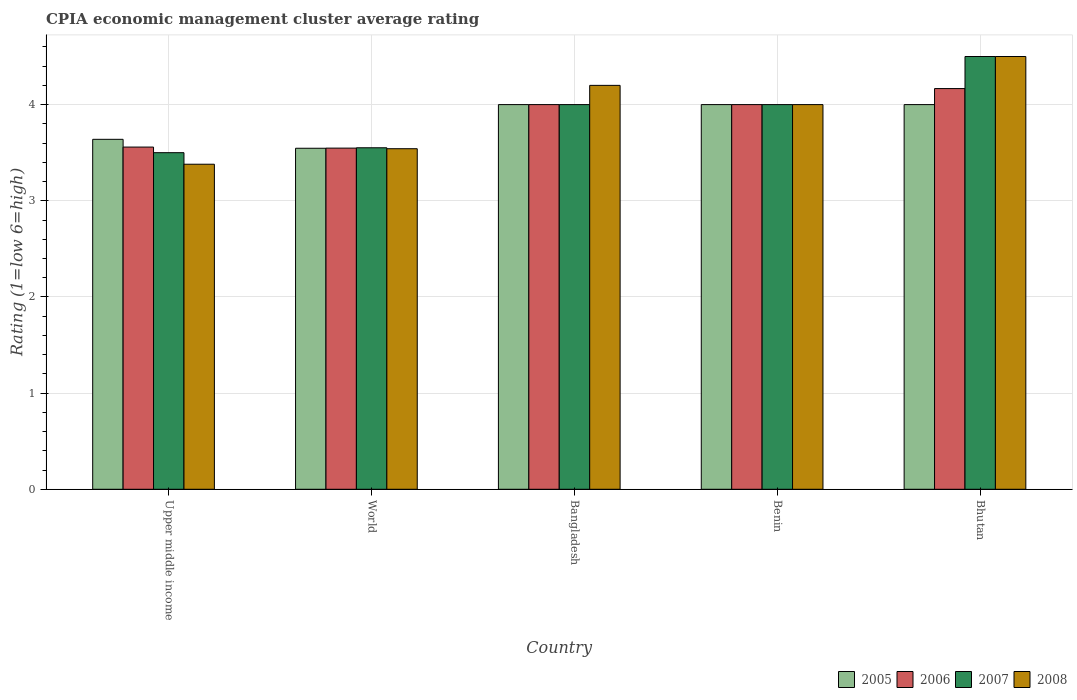Are the number of bars per tick equal to the number of legend labels?
Offer a terse response. Yes. Across all countries, what is the maximum CPIA rating in 2006?
Provide a succinct answer. 4.17. Across all countries, what is the minimum CPIA rating in 2006?
Keep it short and to the point. 3.55. In which country was the CPIA rating in 2008 minimum?
Ensure brevity in your answer.  Upper middle income. What is the total CPIA rating in 2006 in the graph?
Keep it short and to the point. 19.27. What is the difference between the CPIA rating in 2005 in Bangladesh and that in Bhutan?
Make the answer very short. 0. What is the difference between the CPIA rating in 2006 in Upper middle income and the CPIA rating in 2005 in Bhutan?
Provide a succinct answer. -0.44. What is the average CPIA rating in 2007 per country?
Make the answer very short. 3.91. What is the difference between the CPIA rating of/in 2007 and CPIA rating of/in 2006 in Benin?
Ensure brevity in your answer.  0. What is the ratio of the CPIA rating in 2008 in Bhutan to that in World?
Give a very brief answer. 1.27. Is the difference between the CPIA rating in 2007 in Bangladesh and Bhutan greater than the difference between the CPIA rating in 2006 in Bangladesh and Bhutan?
Provide a short and direct response. No. What is the difference between the highest and the lowest CPIA rating in 2007?
Ensure brevity in your answer.  1. Is the sum of the CPIA rating in 2006 in Bangladesh and World greater than the maximum CPIA rating in 2007 across all countries?
Offer a terse response. Yes. Is it the case that in every country, the sum of the CPIA rating in 2007 and CPIA rating in 2005 is greater than the sum of CPIA rating in 2008 and CPIA rating in 2006?
Offer a terse response. No. What does the 1st bar from the left in World represents?
Your answer should be very brief. 2005. What does the 4th bar from the right in Upper middle income represents?
Give a very brief answer. 2005. Is it the case that in every country, the sum of the CPIA rating in 2008 and CPIA rating in 2007 is greater than the CPIA rating in 2005?
Make the answer very short. Yes. What is the difference between two consecutive major ticks on the Y-axis?
Your answer should be compact. 1. Are the values on the major ticks of Y-axis written in scientific E-notation?
Offer a very short reply. No. Does the graph contain grids?
Keep it short and to the point. Yes. Where does the legend appear in the graph?
Make the answer very short. Bottom right. How many legend labels are there?
Make the answer very short. 4. What is the title of the graph?
Provide a short and direct response. CPIA economic management cluster average rating. Does "1989" appear as one of the legend labels in the graph?
Make the answer very short. No. What is the label or title of the Y-axis?
Give a very brief answer. Rating (1=low 6=high). What is the Rating (1=low 6=high) in 2005 in Upper middle income?
Make the answer very short. 3.64. What is the Rating (1=low 6=high) of 2006 in Upper middle income?
Provide a short and direct response. 3.56. What is the Rating (1=low 6=high) in 2007 in Upper middle income?
Make the answer very short. 3.5. What is the Rating (1=low 6=high) of 2008 in Upper middle income?
Provide a succinct answer. 3.38. What is the Rating (1=low 6=high) of 2005 in World?
Make the answer very short. 3.55. What is the Rating (1=low 6=high) in 2006 in World?
Give a very brief answer. 3.55. What is the Rating (1=low 6=high) of 2007 in World?
Keep it short and to the point. 3.55. What is the Rating (1=low 6=high) of 2008 in World?
Your answer should be compact. 3.54. What is the Rating (1=low 6=high) in 2005 in Bangladesh?
Your response must be concise. 4. What is the Rating (1=low 6=high) in 2007 in Bangladesh?
Keep it short and to the point. 4. What is the Rating (1=low 6=high) in 2008 in Bangladesh?
Your response must be concise. 4.2. What is the Rating (1=low 6=high) in 2005 in Benin?
Keep it short and to the point. 4. What is the Rating (1=low 6=high) of 2006 in Benin?
Offer a terse response. 4. What is the Rating (1=low 6=high) in 2005 in Bhutan?
Keep it short and to the point. 4. What is the Rating (1=low 6=high) in 2006 in Bhutan?
Provide a short and direct response. 4.17. What is the Rating (1=low 6=high) in 2008 in Bhutan?
Ensure brevity in your answer.  4.5. Across all countries, what is the maximum Rating (1=low 6=high) of 2006?
Make the answer very short. 4.17. Across all countries, what is the minimum Rating (1=low 6=high) of 2005?
Provide a short and direct response. 3.55. Across all countries, what is the minimum Rating (1=low 6=high) in 2006?
Your answer should be compact. 3.55. Across all countries, what is the minimum Rating (1=low 6=high) in 2007?
Your answer should be compact. 3.5. Across all countries, what is the minimum Rating (1=low 6=high) of 2008?
Give a very brief answer. 3.38. What is the total Rating (1=low 6=high) of 2005 in the graph?
Give a very brief answer. 19.18. What is the total Rating (1=low 6=high) in 2006 in the graph?
Give a very brief answer. 19.27. What is the total Rating (1=low 6=high) in 2007 in the graph?
Provide a succinct answer. 19.55. What is the total Rating (1=low 6=high) of 2008 in the graph?
Your answer should be compact. 19.62. What is the difference between the Rating (1=low 6=high) of 2005 in Upper middle income and that in World?
Your response must be concise. 0.09. What is the difference between the Rating (1=low 6=high) of 2006 in Upper middle income and that in World?
Your answer should be very brief. 0.01. What is the difference between the Rating (1=low 6=high) of 2007 in Upper middle income and that in World?
Your answer should be very brief. -0.05. What is the difference between the Rating (1=low 6=high) of 2008 in Upper middle income and that in World?
Offer a terse response. -0.16. What is the difference between the Rating (1=low 6=high) of 2005 in Upper middle income and that in Bangladesh?
Provide a short and direct response. -0.36. What is the difference between the Rating (1=low 6=high) of 2006 in Upper middle income and that in Bangladesh?
Offer a terse response. -0.44. What is the difference between the Rating (1=low 6=high) in 2008 in Upper middle income and that in Bangladesh?
Your answer should be compact. -0.82. What is the difference between the Rating (1=low 6=high) in 2005 in Upper middle income and that in Benin?
Your answer should be very brief. -0.36. What is the difference between the Rating (1=low 6=high) in 2006 in Upper middle income and that in Benin?
Make the answer very short. -0.44. What is the difference between the Rating (1=low 6=high) of 2008 in Upper middle income and that in Benin?
Make the answer very short. -0.62. What is the difference between the Rating (1=low 6=high) in 2005 in Upper middle income and that in Bhutan?
Offer a very short reply. -0.36. What is the difference between the Rating (1=low 6=high) in 2006 in Upper middle income and that in Bhutan?
Provide a short and direct response. -0.61. What is the difference between the Rating (1=low 6=high) of 2008 in Upper middle income and that in Bhutan?
Offer a very short reply. -1.12. What is the difference between the Rating (1=low 6=high) of 2005 in World and that in Bangladesh?
Ensure brevity in your answer.  -0.45. What is the difference between the Rating (1=low 6=high) of 2006 in World and that in Bangladesh?
Make the answer very short. -0.45. What is the difference between the Rating (1=low 6=high) in 2007 in World and that in Bangladesh?
Keep it short and to the point. -0.45. What is the difference between the Rating (1=low 6=high) of 2008 in World and that in Bangladesh?
Your response must be concise. -0.66. What is the difference between the Rating (1=low 6=high) in 2005 in World and that in Benin?
Ensure brevity in your answer.  -0.45. What is the difference between the Rating (1=low 6=high) in 2006 in World and that in Benin?
Offer a terse response. -0.45. What is the difference between the Rating (1=low 6=high) of 2007 in World and that in Benin?
Offer a very short reply. -0.45. What is the difference between the Rating (1=low 6=high) of 2008 in World and that in Benin?
Your answer should be very brief. -0.46. What is the difference between the Rating (1=low 6=high) of 2005 in World and that in Bhutan?
Keep it short and to the point. -0.45. What is the difference between the Rating (1=low 6=high) in 2006 in World and that in Bhutan?
Provide a succinct answer. -0.62. What is the difference between the Rating (1=low 6=high) in 2007 in World and that in Bhutan?
Offer a terse response. -0.95. What is the difference between the Rating (1=low 6=high) of 2008 in World and that in Bhutan?
Your answer should be compact. -0.96. What is the difference between the Rating (1=low 6=high) of 2005 in Bangladesh and that in Benin?
Your answer should be very brief. 0. What is the difference between the Rating (1=low 6=high) of 2006 in Bangladesh and that in Benin?
Your response must be concise. 0. What is the difference between the Rating (1=low 6=high) of 2007 in Bangladesh and that in Benin?
Offer a very short reply. 0. What is the difference between the Rating (1=low 6=high) of 2008 in Bangladesh and that in Benin?
Give a very brief answer. 0.2. What is the difference between the Rating (1=low 6=high) in 2008 in Bangladesh and that in Bhutan?
Provide a short and direct response. -0.3. What is the difference between the Rating (1=low 6=high) in 2005 in Benin and that in Bhutan?
Provide a short and direct response. 0. What is the difference between the Rating (1=low 6=high) of 2007 in Benin and that in Bhutan?
Your response must be concise. -0.5. What is the difference between the Rating (1=low 6=high) of 2008 in Benin and that in Bhutan?
Provide a succinct answer. -0.5. What is the difference between the Rating (1=low 6=high) in 2005 in Upper middle income and the Rating (1=low 6=high) in 2006 in World?
Your answer should be compact. 0.09. What is the difference between the Rating (1=low 6=high) of 2005 in Upper middle income and the Rating (1=low 6=high) of 2007 in World?
Your answer should be compact. 0.09. What is the difference between the Rating (1=low 6=high) of 2005 in Upper middle income and the Rating (1=low 6=high) of 2008 in World?
Give a very brief answer. 0.1. What is the difference between the Rating (1=low 6=high) in 2006 in Upper middle income and the Rating (1=low 6=high) in 2007 in World?
Give a very brief answer. 0.01. What is the difference between the Rating (1=low 6=high) in 2006 in Upper middle income and the Rating (1=low 6=high) in 2008 in World?
Provide a short and direct response. 0.02. What is the difference between the Rating (1=low 6=high) in 2007 in Upper middle income and the Rating (1=low 6=high) in 2008 in World?
Give a very brief answer. -0.04. What is the difference between the Rating (1=low 6=high) in 2005 in Upper middle income and the Rating (1=low 6=high) in 2006 in Bangladesh?
Make the answer very short. -0.36. What is the difference between the Rating (1=low 6=high) of 2005 in Upper middle income and the Rating (1=low 6=high) of 2007 in Bangladesh?
Your answer should be very brief. -0.36. What is the difference between the Rating (1=low 6=high) in 2005 in Upper middle income and the Rating (1=low 6=high) in 2008 in Bangladesh?
Ensure brevity in your answer.  -0.56. What is the difference between the Rating (1=low 6=high) of 2006 in Upper middle income and the Rating (1=low 6=high) of 2007 in Bangladesh?
Your response must be concise. -0.44. What is the difference between the Rating (1=low 6=high) in 2006 in Upper middle income and the Rating (1=low 6=high) in 2008 in Bangladesh?
Your response must be concise. -0.64. What is the difference between the Rating (1=low 6=high) of 2007 in Upper middle income and the Rating (1=low 6=high) of 2008 in Bangladesh?
Your answer should be very brief. -0.7. What is the difference between the Rating (1=low 6=high) of 2005 in Upper middle income and the Rating (1=low 6=high) of 2006 in Benin?
Your answer should be very brief. -0.36. What is the difference between the Rating (1=low 6=high) in 2005 in Upper middle income and the Rating (1=low 6=high) in 2007 in Benin?
Give a very brief answer. -0.36. What is the difference between the Rating (1=low 6=high) of 2005 in Upper middle income and the Rating (1=low 6=high) of 2008 in Benin?
Offer a very short reply. -0.36. What is the difference between the Rating (1=low 6=high) of 2006 in Upper middle income and the Rating (1=low 6=high) of 2007 in Benin?
Keep it short and to the point. -0.44. What is the difference between the Rating (1=low 6=high) of 2006 in Upper middle income and the Rating (1=low 6=high) of 2008 in Benin?
Your answer should be compact. -0.44. What is the difference between the Rating (1=low 6=high) of 2007 in Upper middle income and the Rating (1=low 6=high) of 2008 in Benin?
Provide a short and direct response. -0.5. What is the difference between the Rating (1=low 6=high) of 2005 in Upper middle income and the Rating (1=low 6=high) of 2006 in Bhutan?
Your answer should be very brief. -0.53. What is the difference between the Rating (1=low 6=high) of 2005 in Upper middle income and the Rating (1=low 6=high) of 2007 in Bhutan?
Give a very brief answer. -0.86. What is the difference between the Rating (1=low 6=high) in 2005 in Upper middle income and the Rating (1=low 6=high) in 2008 in Bhutan?
Offer a terse response. -0.86. What is the difference between the Rating (1=low 6=high) in 2006 in Upper middle income and the Rating (1=low 6=high) in 2007 in Bhutan?
Offer a terse response. -0.94. What is the difference between the Rating (1=low 6=high) in 2006 in Upper middle income and the Rating (1=low 6=high) in 2008 in Bhutan?
Offer a very short reply. -0.94. What is the difference between the Rating (1=low 6=high) of 2005 in World and the Rating (1=low 6=high) of 2006 in Bangladesh?
Your answer should be very brief. -0.45. What is the difference between the Rating (1=low 6=high) of 2005 in World and the Rating (1=low 6=high) of 2007 in Bangladesh?
Ensure brevity in your answer.  -0.45. What is the difference between the Rating (1=low 6=high) in 2005 in World and the Rating (1=low 6=high) in 2008 in Bangladesh?
Offer a terse response. -0.65. What is the difference between the Rating (1=low 6=high) of 2006 in World and the Rating (1=low 6=high) of 2007 in Bangladesh?
Offer a very short reply. -0.45. What is the difference between the Rating (1=low 6=high) in 2006 in World and the Rating (1=low 6=high) in 2008 in Bangladesh?
Keep it short and to the point. -0.65. What is the difference between the Rating (1=low 6=high) in 2007 in World and the Rating (1=low 6=high) in 2008 in Bangladesh?
Make the answer very short. -0.65. What is the difference between the Rating (1=low 6=high) of 2005 in World and the Rating (1=low 6=high) of 2006 in Benin?
Provide a short and direct response. -0.45. What is the difference between the Rating (1=low 6=high) in 2005 in World and the Rating (1=low 6=high) in 2007 in Benin?
Make the answer very short. -0.45. What is the difference between the Rating (1=low 6=high) in 2005 in World and the Rating (1=low 6=high) in 2008 in Benin?
Offer a terse response. -0.45. What is the difference between the Rating (1=low 6=high) in 2006 in World and the Rating (1=low 6=high) in 2007 in Benin?
Provide a succinct answer. -0.45. What is the difference between the Rating (1=low 6=high) of 2006 in World and the Rating (1=low 6=high) of 2008 in Benin?
Provide a short and direct response. -0.45. What is the difference between the Rating (1=low 6=high) in 2007 in World and the Rating (1=low 6=high) in 2008 in Benin?
Provide a short and direct response. -0.45. What is the difference between the Rating (1=low 6=high) in 2005 in World and the Rating (1=low 6=high) in 2006 in Bhutan?
Your answer should be very brief. -0.62. What is the difference between the Rating (1=low 6=high) in 2005 in World and the Rating (1=low 6=high) in 2007 in Bhutan?
Give a very brief answer. -0.95. What is the difference between the Rating (1=low 6=high) of 2005 in World and the Rating (1=low 6=high) of 2008 in Bhutan?
Keep it short and to the point. -0.95. What is the difference between the Rating (1=low 6=high) in 2006 in World and the Rating (1=low 6=high) in 2007 in Bhutan?
Keep it short and to the point. -0.95. What is the difference between the Rating (1=low 6=high) of 2006 in World and the Rating (1=low 6=high) of 2008 in Bhutan?
Your answer should be compact. -0.95. What is the difference between the Rating (1=low 6=high) in 2007 in World and the Rating (1=low 6=high) in 2008 in Bhutan?
Keep it short and to the point. -0.95. What is the difference between the Rating (1=low 6=high) of 2005 in Bangladesh and the Rating (1=low 6=high) of 2006 in Benin?
Your response must be concise. 0. What is the difference between the Rating (1=low 6=high) in 2005 in Bangladesh and the Rating (1=low 6=high) in 2007 in Benin?
Keep it short and to the point. 0. What is the difference between the Rating (1=low 6=high) of 2006 in Bangladesh and the Rating (1=low 6=high) of 2008 in Benin?
Your answer should be very brief. 0. What is the difference between the Rating (1=low 6=high) in 2005 in Bangladesh and the Rating (1=low 6=high) in 2007 in Bhutan?
Make the answer very short. -0.5. What is the difference between the Rating (1=low 6=high) in 2005 in Bangladesh and the Rating (1=low 6=high) in 2008 in Bhutan?
Your answer should be compact. -0.5. What is the difference between the Rating (1=low 6=high) in 2005 in Benin and the Rating (1=low 6=high) in 2006 in Bhutan?
Give a very brief answer. -0.17. What is the difference between the Rating (1=low 6=high) of 2006 in Benin and the Rating (1=low 6=high) of 2007 in Bhutan?
Offer a very short reply. -0.5. What is the difference between the Rating (1=low 6=high) of 2007 in Benin and the Rating (1=low 6=high) of 2008 in Bhutan?
Your answer should be compact. -0.5. What is the average Rating (1=low 6=high) of 2005 per country?
Offer a very short reply. 3.84. What is the average Rating (1=low 6=high) in 2006 per country?
Provide a short and direct response. 3.85. What is the average Rating (1=low 6=high) of 2007 per country?
Offer a very short reply. 3.91. What is the average Rating (1=low 6=high) of 2008 per country?
Give a very brief answer. 3.92. What is the difference between the Rating (1=low 6=high) of 2005 and Rating (1=low 6=high) of 2006 in Upper middle income?
Give a very brief answer. 0.08. What is the difference between the Rating (1=low 6=high) of 2005 and Rating (1=low 6=high) of 2007 in Upper middle income?
Offer a very short reply. 0.14. What is the difference between the Rating (1=low 6=high) of 2005 and Rating (1=low 6=high) of 2008 in Upper middle income?
Your answer should be compact. 0.26. What is the difference between the Rating (1=low 6=high) of 2006 and Rating (1=low 6=high) of 2007 in Upper middle income?
Your response must be concise. 0.06. What is the difference between the Rating (1=low 6=high) of 2006 and Rating (1=low 6=high) of 2008 in Upper middle income?
Provide a succinct answer. 0.18. What is the difference between the Rating (1=low 6=high) in 2007 and Rating (1=low 6=high) in 2008 in Upper middle income?
Provide a succinct answer. 0.12. What is the difference between the Rating (1=low 6=high) in 2005 and Rating (1=low 6=high) in 2006 in World?
Provide a short and direct response. -0. What is the difference between the Rating (1=low 6=high) in 2005 and Rating (1=low 6=high) in 2007 in World?
Provide a short and direct response. -0.01. What is the difference between the Rating (1=low 6=high) in 2005 and Rating (1=low 6=high) in 2008 in World?
Your answer should be compact. 0. What is the difference between the Rating (1=low 6=high) in 2006 and Rating (1=low 6=high) in 2007 in World?
Your answer should be very brief. -0. What is the difference between the Rating (1=low 6=high) of 2006 and Rating (1=low 6=high) of 2008 in World?
Keep it short and to the point. 0.01. What is the difference between the Rating (1=low 6=high) of 2007 and Rating (1=low 6=high) of 2008 in World?
Offer a very short reply. 0.01. What is the difference between the Rating (1=low 6=high) of 2005 and Rating (1=low 6=high) of 2006 in Bangladesh?
Provide a succinct answer. 0. What is the difference between the Rating (1=low 6=high) of 2006 and Rating (1=low 6=high) of 2007 in Bangladesh?
Offer a very short reply. 0. What is the difference between the Rating (1=low 6=high) in 2005 and Rating (1=low 6=high) in 2006 in Benin?
Your response must be concise. 0. What is the difference between the Rating (1=low 6=high) in 2005 and Rating (1=low 6=high) in 2007 in Benin?
Ensure brevity in your answer.  0. What is the difference between the Rating (1=low 6=high) in 2006 and Rating (1=low 6=high) in 2008 in Benin?
Your answer should be compact. 0. What is the difference between the Rating (1=low 6=high) of 2005 and Rating (1=low 6=high) of 2006 in Bhutan?
Your response must be concise. -0.17. What is the difference between the Rating (1=low 6=high) in 2005 and Rating (1=low 6=high) in 2007 in Bhutan?
Your response must be concise. -0.5. What is the difference between the Rating (1=low 6=high) of 2005 and Rating (1=low 6=high) of 2008 in Bhutan?
Offer a terse response. -0.5. What is the difference between the Rating (1=low 6=high) in 2006 and Rating (1=low 6=high) in 2008 in Bhutan?
Your answer should be compact. -0.33. What is the ratio of the Rating (1=low 6=high) in 2005 in Upper middle income to that in World?
Offer a very short reply. 1.03. What is the ratio of the Rating (1=low 6=high) of 2006 in Upper middle income to that in World?
Make the answer very short. 1. What is the ratio of the Rating (1=low 6=high) of 2007 in Upper middle income to that in World?
Provide a succinct answer. 0.99. What is the ratio of the Rating (1=low 6=high) of 2008 in Upper middle income to that in World?
Make the answer very short. 0.95. What is the ratio of the Rating (1=low 6=high) in 2005 in Upper middle income to that in Bangladesh?
Offer a terse response. 0.91. What is the ratio of the Rating (1=low 6=high) of 2006 in Upper middle income to that in Bangladesh?
Offer a very short reply. 0.89. What is the ratio of the Rating (1=low 6=high) of 2007 in Upper middle income to that in Bangladesh?
Your response must be concise. 0.88. What is the ratio of the Rating (1=low 6=high) of 2008 in Upper middle income to that in Bangladesh?
Offer a very short reply. 0.8. What is the ratio of the Rating (1=low 6=high) in 2005 in Upper middle income to that in Benin?
Keep it short and to the point. 0.91. What is the ratio of the Rating (1=low 6=high) in 2006 in Upper middle income to that in Benin?
Make the answer very short. 0.89. What is the ratio of the Rating (1=low 6=high) in 2008 in Upper middle income to that in Benin?
Keep it short and to the point. 0.84. What is the ratio of the Rating (1=low 6=high) in 2005 in Upper middle income to that in Bhutan?
Provide a short and direct response. 0.91. What is the ratio of the Rating (1=low 6=high) of 2006 in Upper middle income to that in Bhutan?
Your answer should be compact. 0.85. What is the ratio of the Rating (1=low 6=high) of 2007 in Upper middle income to that in Bhutan?
Give a very brief answer. 0.78. What is the ratio of the Rating (1=low 6=high) in 2008 in Upper middle income to that in Bhutan?
Your answer should be very brief. 0.75. What is the ratio of the Rating (1=low 6=high) in 2005 in World to that in Bangladesh?
Keep it short and to the point. 0.89. What is the ratio of the Rating (1=low 6=high) of 2006 in World to that in Bangladesh?
Your answer should be compact. 0.89. What is the ratio of the Rating (1=low 6=high) in 2007 in World to that in Bangladesh?
Your response must be concise. 0.89. What is the ratio of the Rating (1=low 6=high) in 2008 in World to that in Bangladesh?
Your response must be concise. 0.84. What is the ratio of the Rating (1=low 6=high) in 2005 in World to that in Benin?
Provide a short and direct response. 0.89. What is the ratio of the Rating (1=low 6=high) in 2006 in World to that in Benin?
Provide a short and direct response. 0.89. What is the ratio of the Rating (1=low 6=high) in 2007 in World to that in Benin?
Provide a succinct answer. 0.89. What is the ratio of the Rating (1=low 6=high) of 2008 in World to that in Benin?
Keep it short and to the point. 0.89. What is the ratio of the Rating (1=low 6=high) in 2005 in World to that in Bhutan?
Offer a terse response. 0.89. What is the ratio of the Rating (1=low 6=high) of 2006 in World to that in Bhutan?
Provide a succinct answer. 0.85. What is the ratio of the Rating (1=low 6=high) of 2007 in World to that in Bhutan?
Your answer should be very brief. 0.79. What is the ratio of the Rating (1=low 6=high) in 2008 in World to that in Bhutan?
Ensure brevity in your answer.  0.79. What is the ratio of the Rating (1=low 6=high) in 2006 in Bangladesh to that in Benin?
Provide a succinct answer. 1. What is the ratio of the Rating (1=low 6=high) in 2007 in Bangladesh to that in Benin?
Your answer should be very brief. 1. What is the ratio of the Rating (1=low 6=high) of 2008 in Bangladesh to that in Benin?
Offer a terse response. 1.05. What is the ratio of the Rating (1=low 6=high) in 2006 in Bangladesh to that in Bhutan?
Provide a succinct answer. 0.96. What is the ratio of the Rating (1=low 6=high) in 2007 in Bangladesh to that in Bhutan?
Offer a very short reply. 0.89. What is the ratio of the Rating (1=low 6=high) of 2008 in Bangladesh to that in Bhutan?
Give a very brief answer. 0.93. What is the ratio of the Rating (1=low 6=high) in 2005 in Benin to that in Bhutan?
Provide a short and direct response. 1. What is the difference between the highest and the second highest Rating (1=low 6=high) in 2005?
Your response must be concise. 0. What is the difference between the highest and the second highest Rating (1=low 6=high) of 2006?
Give a very brief answer. 0.17. What is the difference between the highest and the lowest Rating (1=low 6=high) of 2005?
Your response must be concise. 0.45. What is the difference between the highest and the lowest Rating (1=low 6=high) in 2006?
Your response must be concise. 0.62. What is the difference between the highest and the lowest Rating (1=low 6=high) in 2008?
Ensure brevity in your answer.  1.12. 